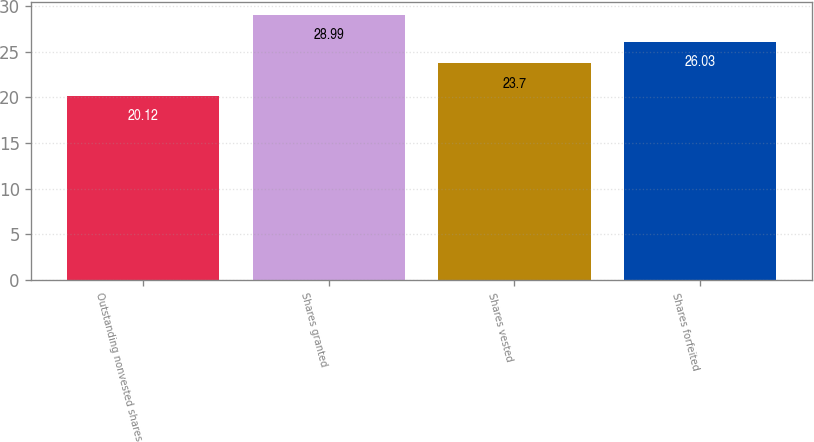Convert chart to OTSL. <chart><loc_0><loc_0><loc_500><loc_500><bar_chart><fcel>Outstanding nonvested shares<fcel>Shares granted<fcel>Shares vested<fcel>Shares forfeited<nl><fcel>20.12<fcel>28.99<fcel>23.7<fcel>26.03<nl></chart> 